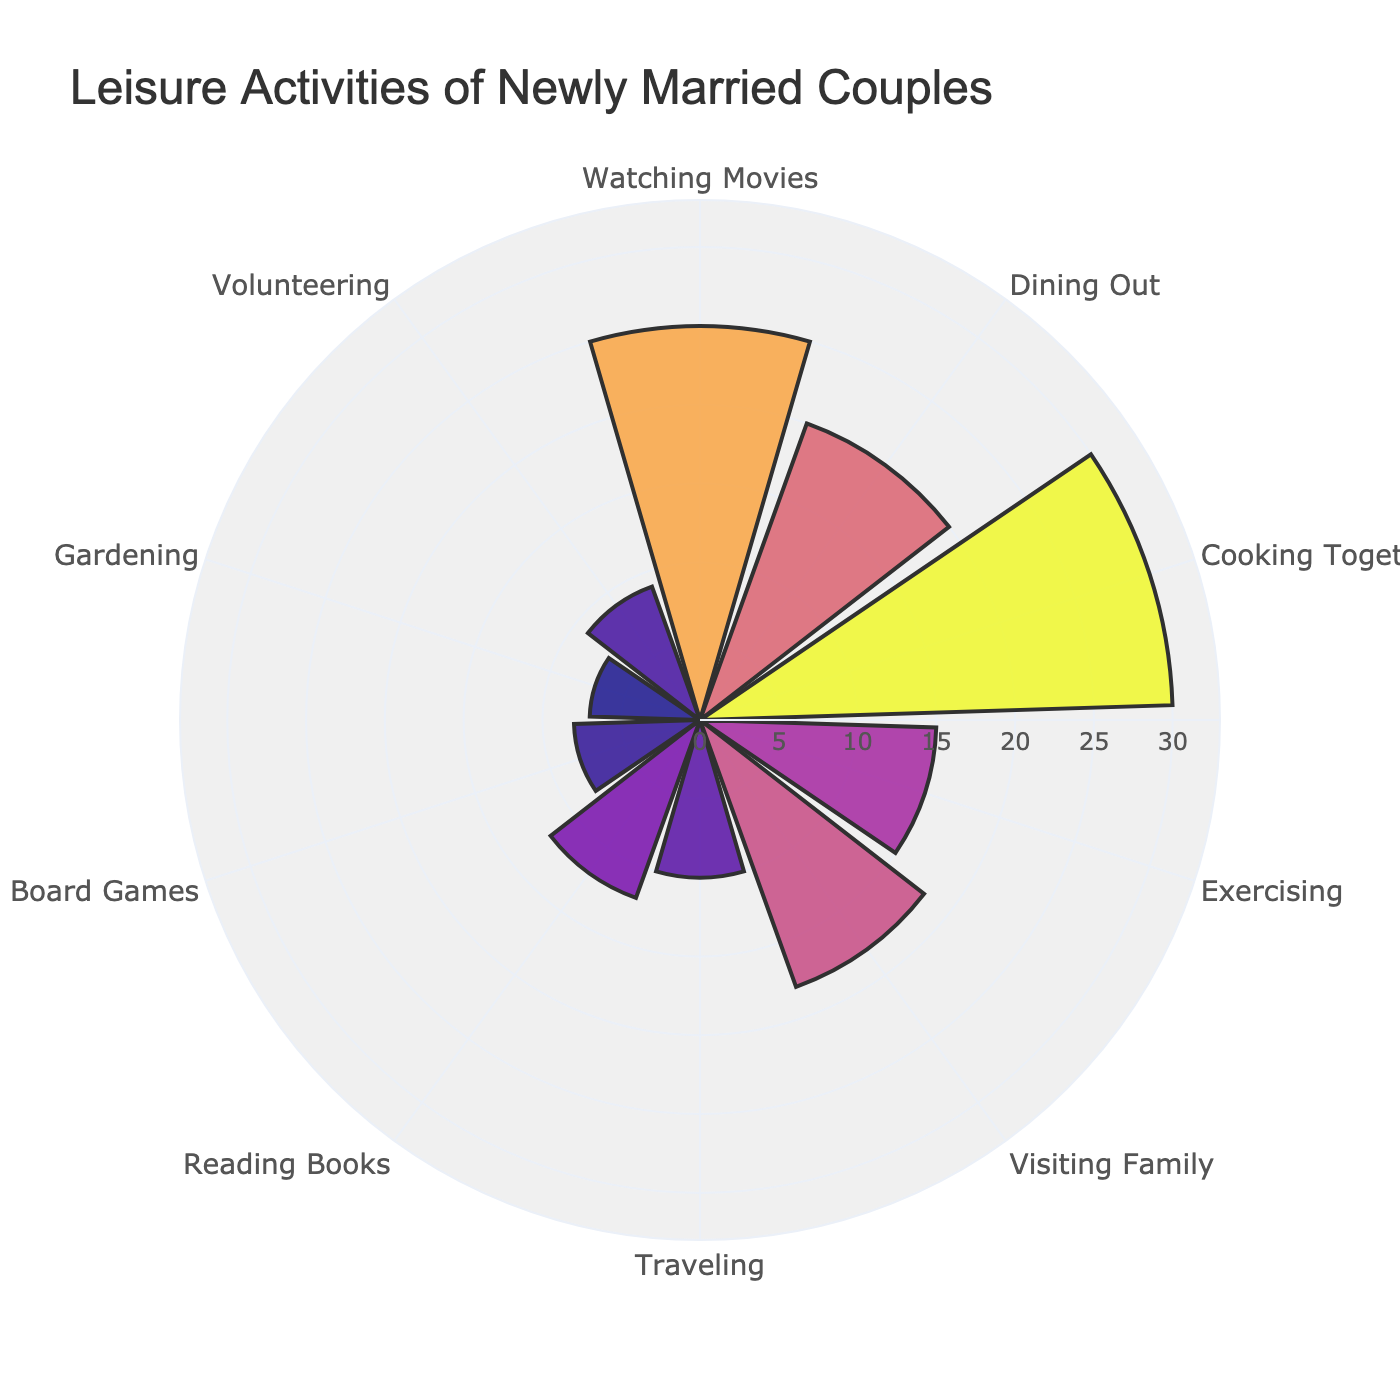What's the title of the figure? The title of the figure is prominently displayed at the top. It reads, "Leisure Activities of Newly Married Couples."
Answer: Leisure Activities of Newly Married Couples Which activity has the highest frequency? By observing the lengths of the bars, "Cooking Together" has the longest bar, indicating it has the highest frequency.
Answer: Cooking Together How frequently do newly married couples watch movies? The bar for "Watching Movies" displays a frequency. Checking this bar shows a frequency of 25.
Answer: 25 Which activity is least frequent? The shortest bar represents the least frequent activity. "Gardening" has the shortest bar, indicating it has the lowest frequency.
Answer: Gardening How many activities have a frequency higher than 15? Count the bars that extend above the 15 mark on the radial axis. These activities are "Watching Movies," "Dining Out," "Cooking Together," and "Visiting Family." There are 4 such activities.
Answer: 4 What's the sum of the frequencies of "Traveling" and "Reading Books"? Add the frequencies of "Traveling" (10) and "Reading Books" (12). So, 10 + 12 = 22.
Answer: 22 What is the average frequency of all listed activities? Sum all frequencies: 25 + 20 + 30 + 15 + 18 + 10 + 12 + 8 + 7 + 9 = 154. There are 10 activities, so the average is 154 / 10 = 15.4.
Answer: 15.4 Which activity is more frequent, "Exercising" or "Visiting Family"? Compare the lengths of the bars for "Exercising" and "Visiting Family." The "Visiting Family" bar is longer.
Answer: Visiting Family Is the frequency of "Volunteering" greater than or equal to that of "Playing Board Games"? Compare the bars of "Volunteering" and "Playing Board Games." "Volunteering" has a frequency of 9, and "Playing Board Games" has a frequency of 8. 9 is greater than 8.
Answer: Yes How is the radial axis labeled? The radial axis labels frequencies and range from 0 to a value slightly above the maximum frequency observed. The highest value shown is just above 30.
Answer: Ranges from 0 to just above 30 